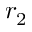Convert formula to latex. <formula><loc_0><loc_0><loc_500><loc_500>r _ { 2 }</formula> 